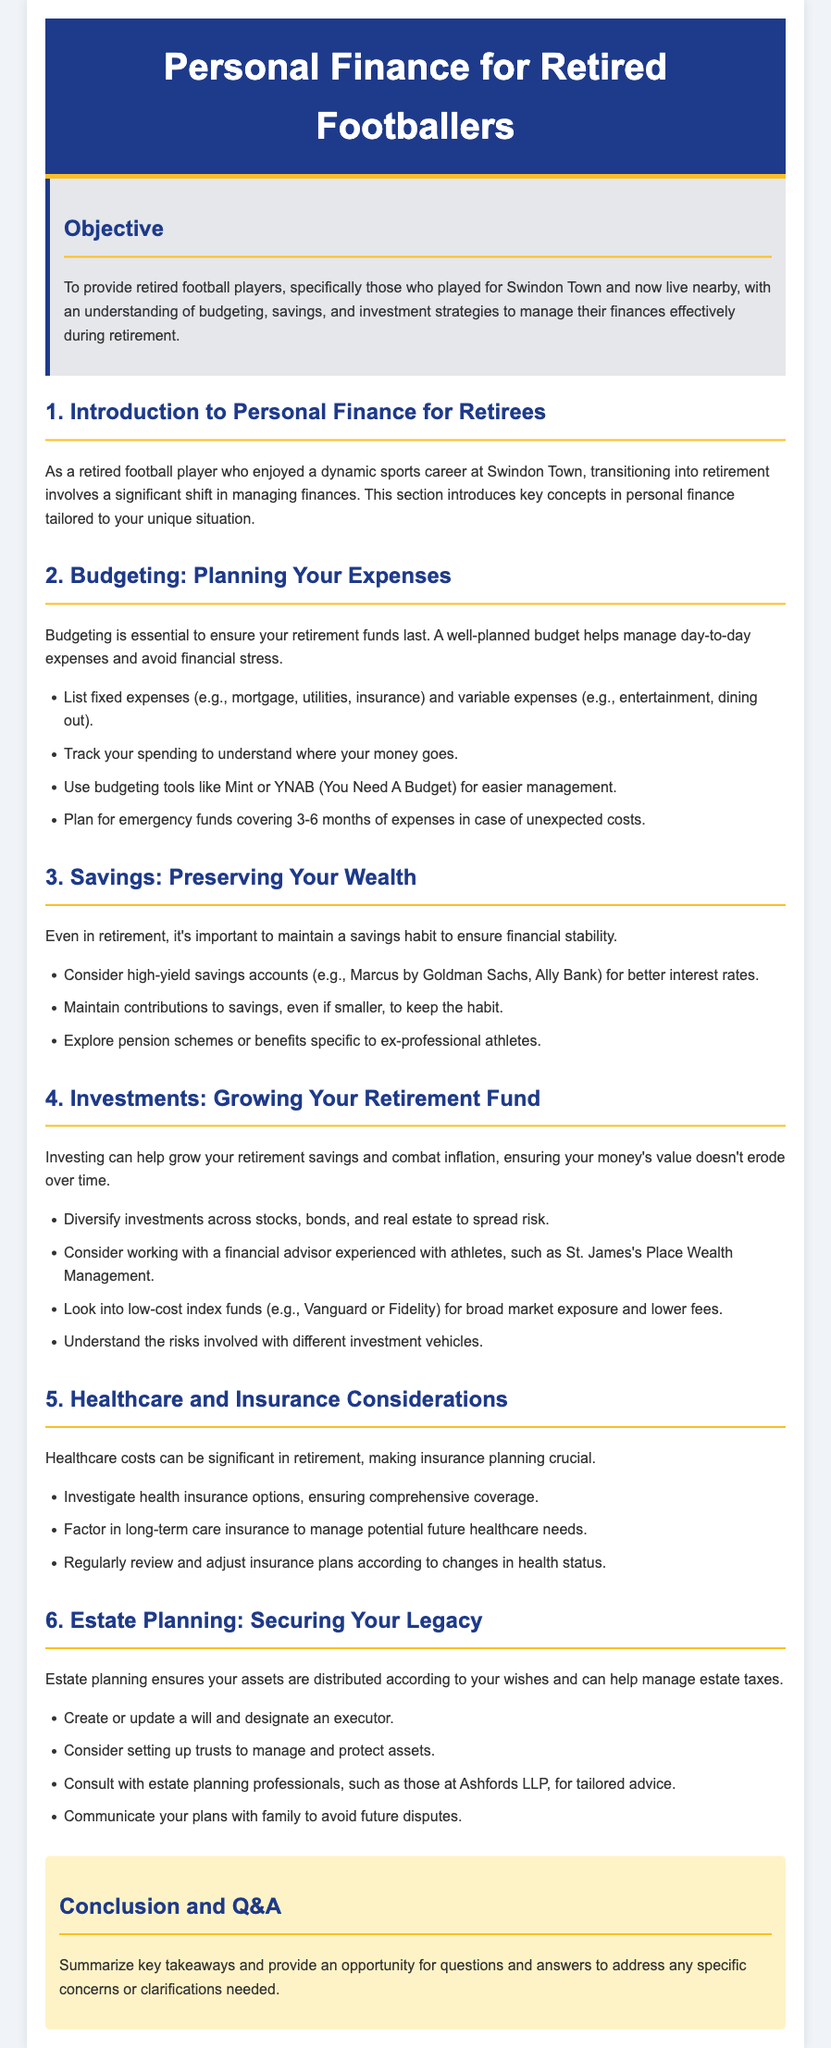What is the title of the lesson plan? The title is stated at the beginning of the document, indicating the main focus of the content.
Answer: Personal Finance for Retired Footballers Who is the target audience for the lesson plan? The target audience is specified in the objective section of the document.
Answer: Retired football players What is one recommended budgeting tool mentioned? The document lists specific budgeting tools to help with financial management.
Answer: Mint What is the duration suggested for an emergency fund? The document provides a guideline for how many months of expenses should be covered.
Answer: 3-6 months Which type of insurance is suggested for long-term needs? The document discusses important insurance considerations related to healthcare in retirement.
Answer: Long-term care insurance What is highlighted as essential for managing retirement funds? The document emphasizes the importance of planning in managing financial resources.
Answer: Budgeting What should be created or updated as part of estate planning? The document outlines key actions needed to secure one’s legacy effectively.
Answer: A will Which professional is mentioned for tailored estate planning advice? The document specifies a professional service to consider when planning one's estate.
Answer: Ashfords LLP What is a benefit of diversifying investments? The document explains a particular financial strategy to minimize risk.
Answer: Spread risk 